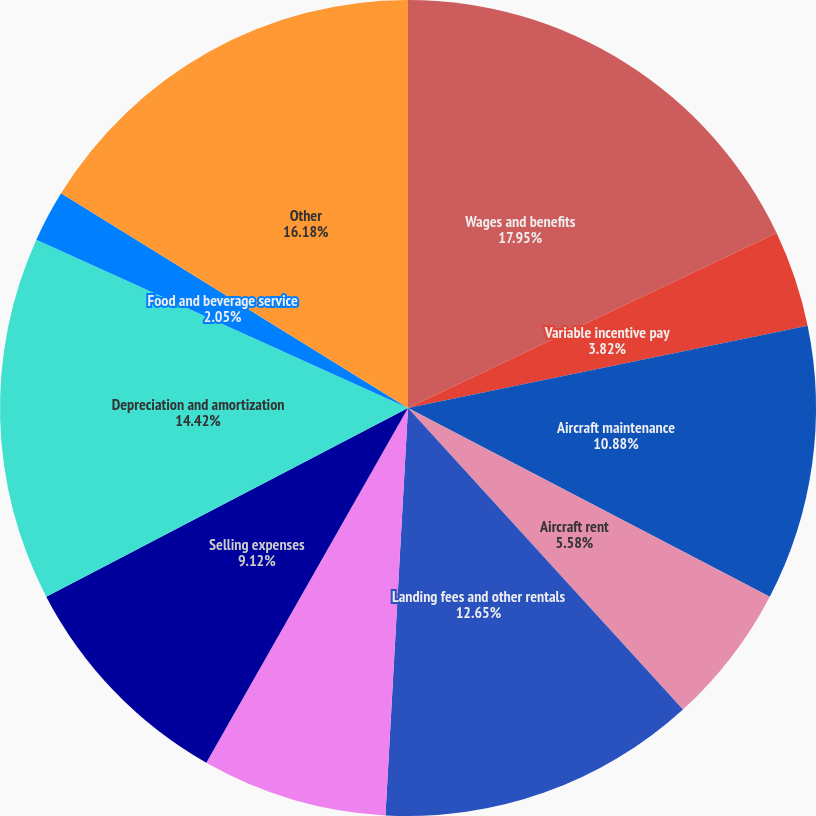<chart> <loc_0><loc_0><loc_500><loc_500><pie_chart><fcel>Wages and benefits<fcel>Variable incentive pay<fcel>Aircraft maintenance<fcel>Aircraft rent<fcel>Landing fees and other rentals<fcel>Contracted services<fcel>Selling expenses<fcel>Depreciation and amortization<fcel>Food and beverage service<fcel>Other<nl><fcel>17.95%<fcel>3.82%<fcel>10.88%<fcel>5.58%<fcel>12.65%<fcel>7.35%<fcel>9.12%<fcel>14.42%<fcel>2.05%<fcel>16.18%<nl></chart> 